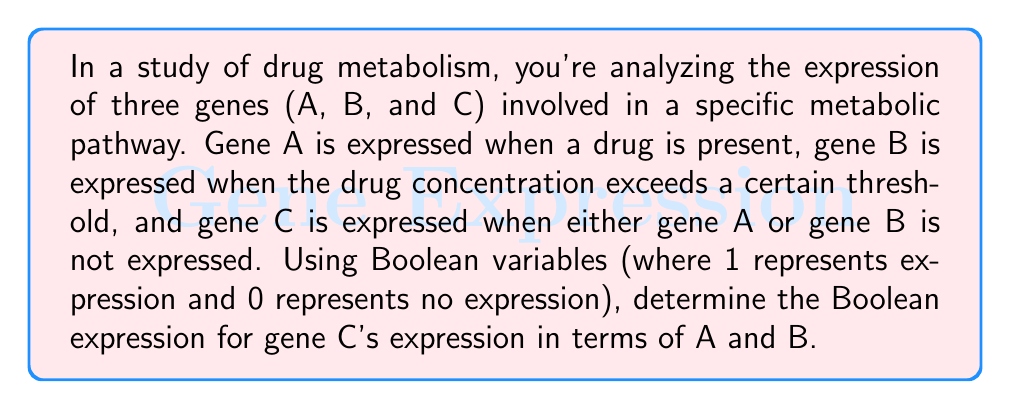Give your solution to this math problem. Let's approach this step-by-step using Boolean algebra:

1) First, let's define our variables:
   A = 1 when gene A is expressed (drug is present)
   B = 1 when gene B is expressed (drug concentration above threshold)
   C = 1 when gene C is expressed

2) We're told that C is expressed when either A or B is not expressed. In Boolean terms, this means C is the NOR of A and B.

3) The NOR operation is true when both inputs are false. In Boolean algebra, this can be written as:

   $C = \overline{A + B}$

4) Using De Morgan's law, we can rewrite this as:

   $C = \overline{A} \cdot \overline{B}$

5) This expression means that C is expressed (C = 1) only when both A and B are not expressed (A = 0 and B = 0).

6) We can verify this with a truth table:

   | A | B | C |
   |---|---|---|
   | 0 | 0 | 1 |
   | 0 | 1 | 0 |
   | 1 | 0 | 0 |
   | 1 | 1 | 0 |

   This confirms our Boolean expression is correct.
Answer: $C = \overline{A} \cdot \overline{B}$ 